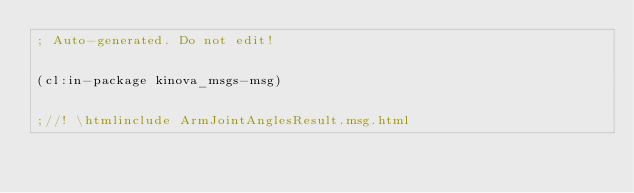<code> <loc_0><loc_0><loc_500><loc_500><_Lisp_>; Auto-generated. Do not edit!


(cl:in-package kinova_msgs-msg)


;//! \htmlinclude ArmJointAnglesResult.msg.html
</code> 